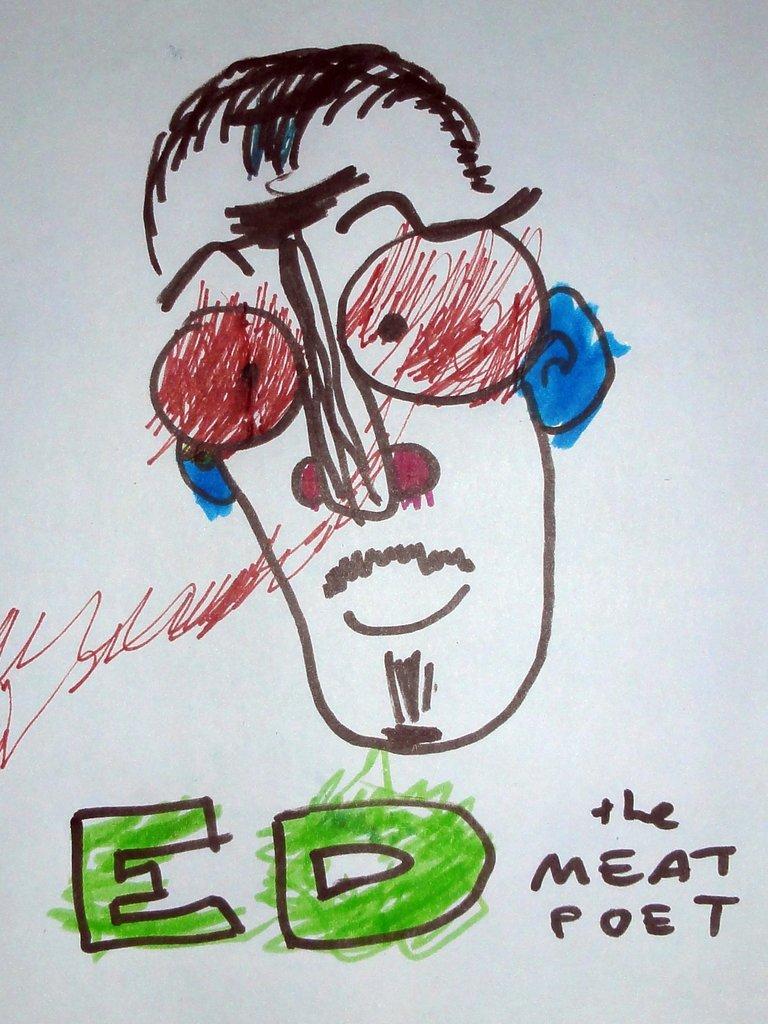Could you give a brief overview of what you see in this image? In this image there is a drawing and there is some text written on the paper. 